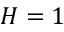Convert formula to latex. <formula><loc_0><loc_0><loc_500><loc_500>H = 1</formula> 